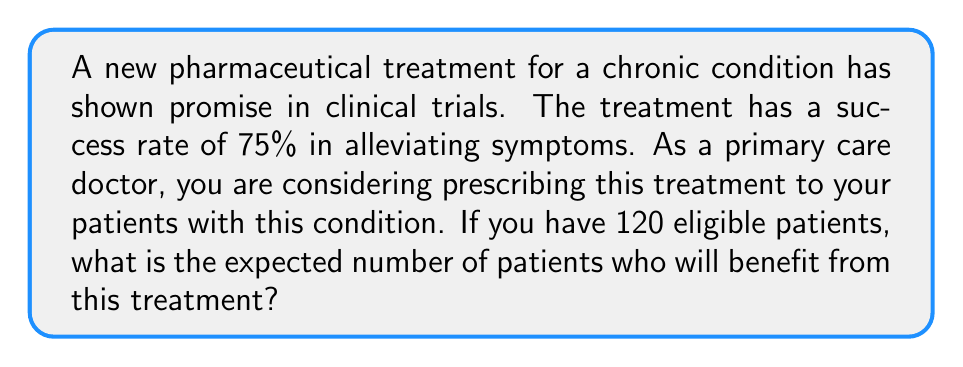Provide a solution to this math problem. To solve this problem, we need to use the concept of expected value for a binomial distribution. Let's break it down step-by-step:

1) First, we identify the random variable:
   Let X be the number of patients who benefit from the treatment.

2) We know that X follows a binomial distribution with parameters:
   n = 120 (total number of patients)
   p = 0.75 (probability of success for each patient)

3) The expected value of a binomial distribution is given by:
   $$E(X) = np$$

4) Substituting our values:
   $$E(X) = 120 \times 0.75$$

5) Calculate:
   $$E(X) = 90$$

Therefore, the expected number of patients who will benefit from the treatment is 90.

This calculation helps the primary care doctor understand the potential impact of the new treatment on their patient population, allowing for informed decision-making when considering whether to prescribe this new pharmaceutical product.
Answer: 90 patients 